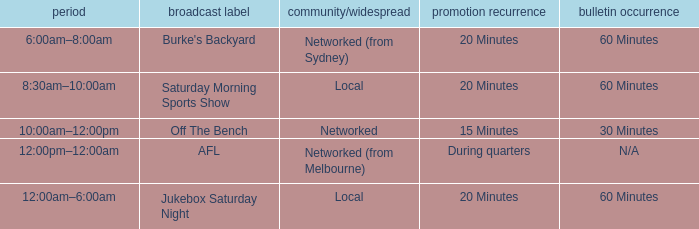What is the ad frequency for the Show Off The Bench? 15 Minutes. 